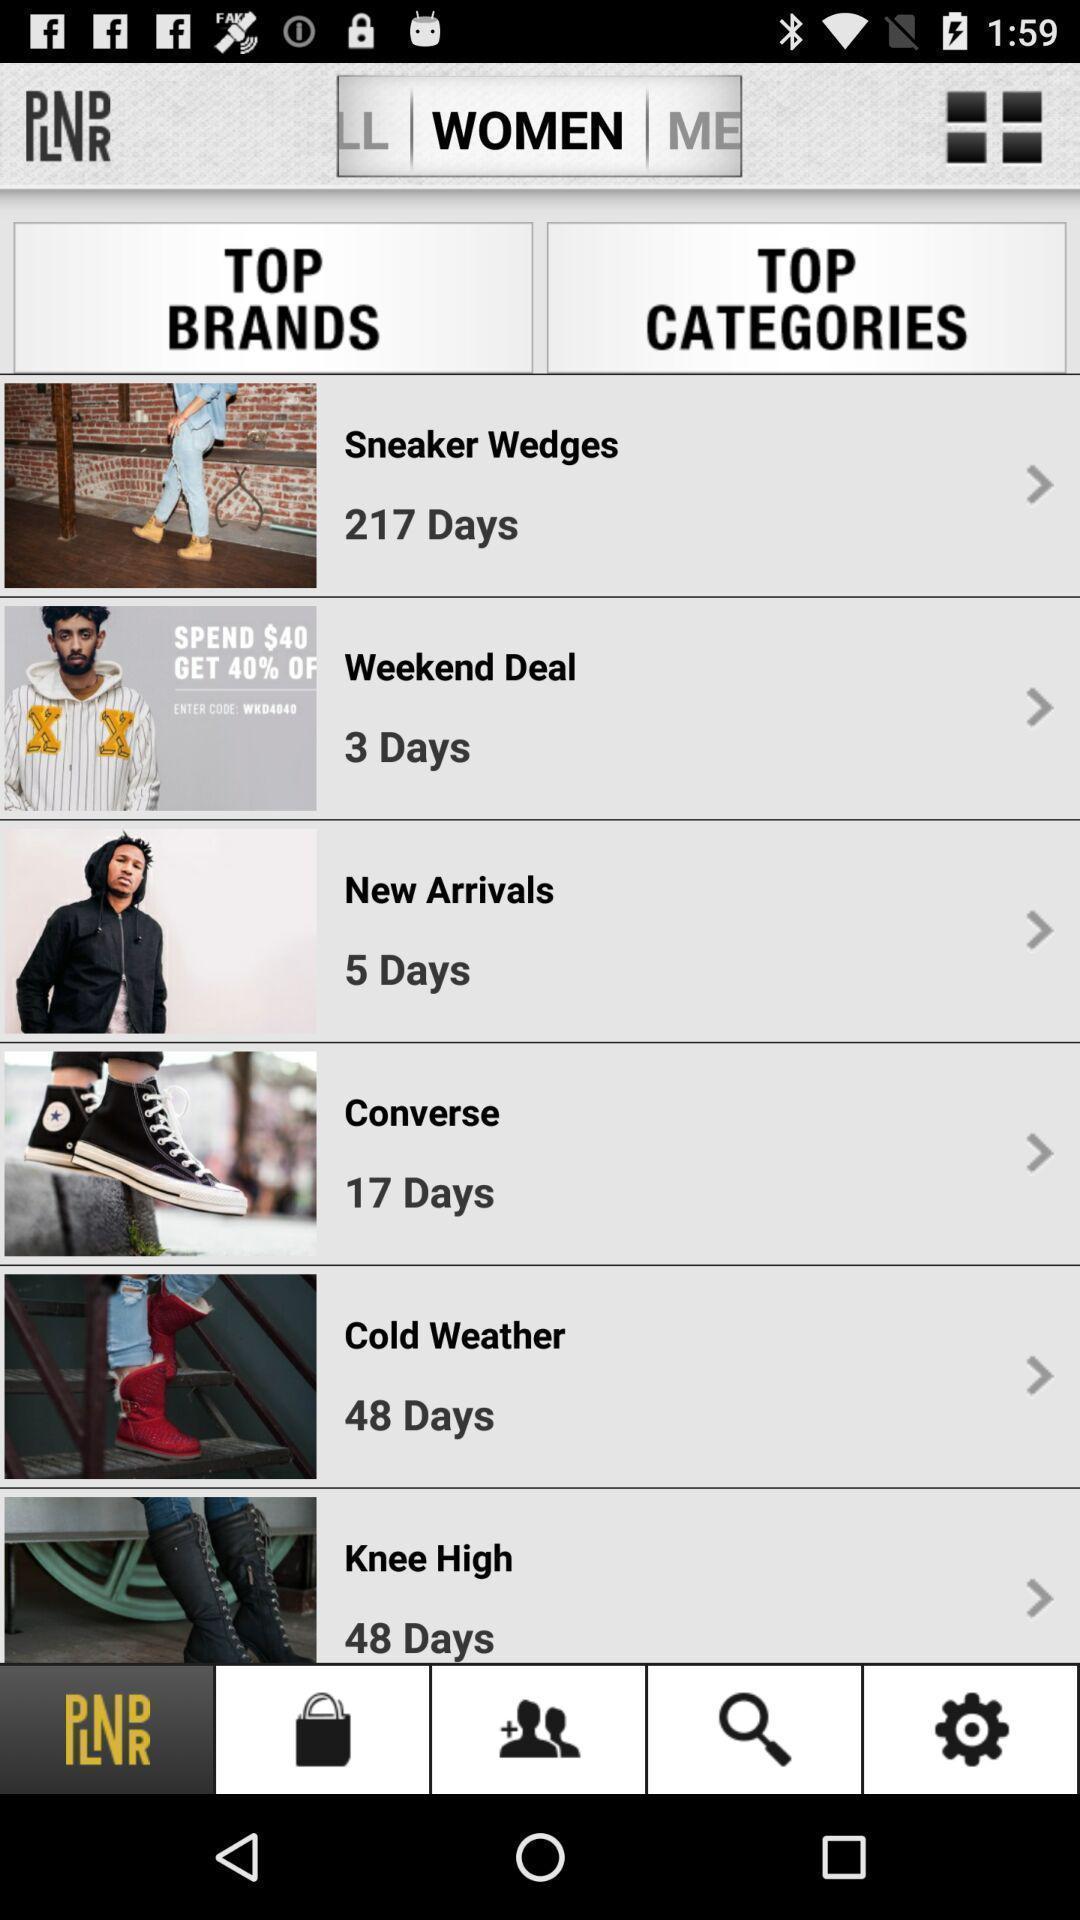Describe the key features of this screenshot. Page showing different categories in shopping app. 